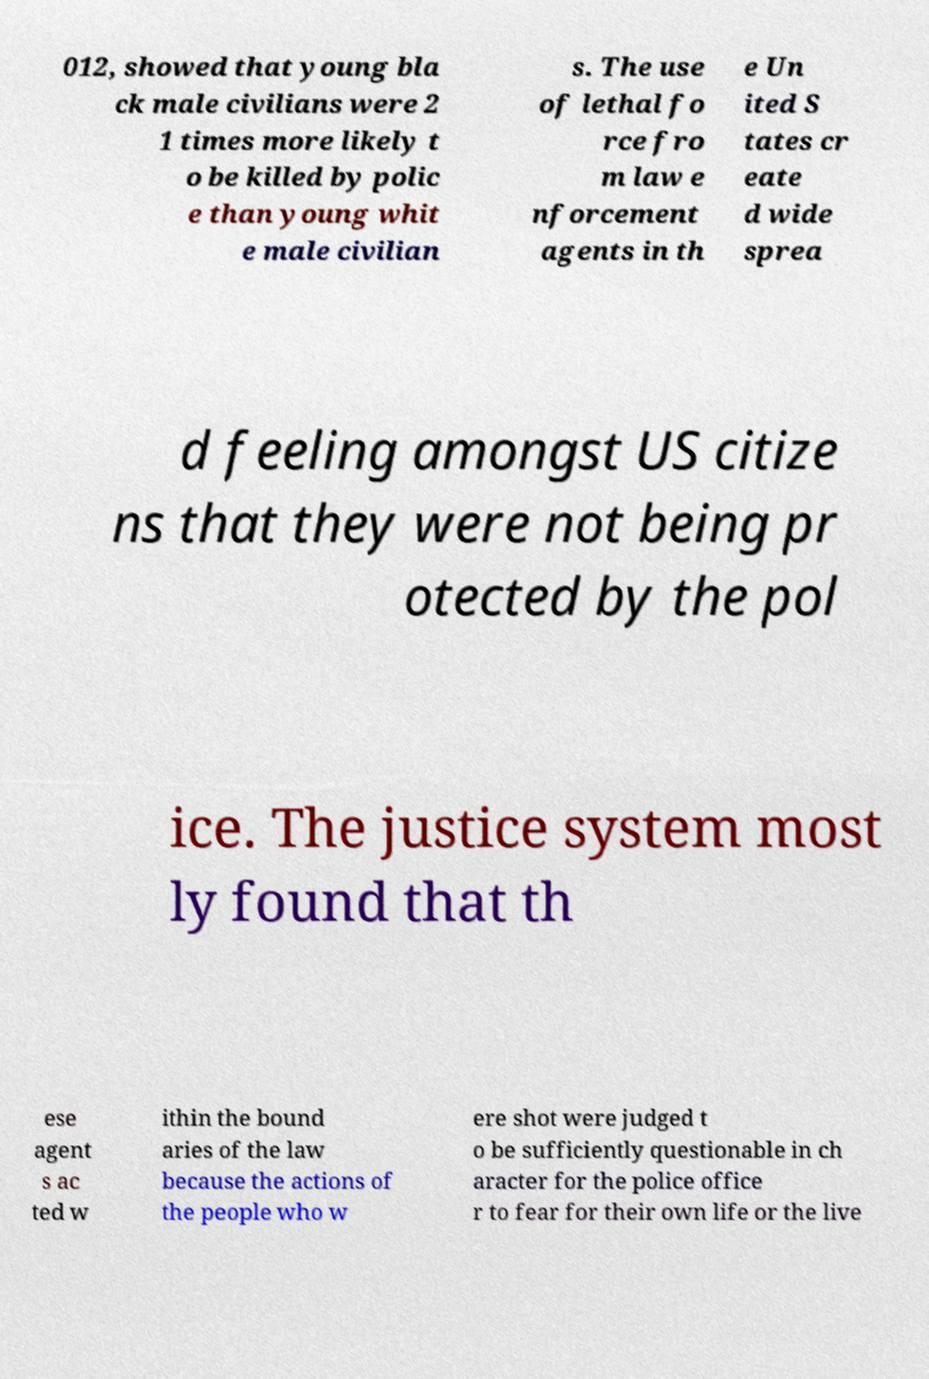Could you assist in decoding the text presented in this image and type it out clearly? 012, showed that young bla ck male civilians were 2 1 times more likely t o be killed by polic e than young whit e male civilian s. The use of lethal fo rce fro m law e nforcement agents in th e Un ited S tates cr eate d wide sprea d feeling amongst US citize ns that they were not being pr otected by the pol ice. The justice system most ly found that th ese agent s ac ted w ithin the bound aries of the law because the actions of the people who w ere shot were judged t o be sufficiently questionable in ch aracter for the police office r to fear for their own life or the live 